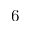<formula> <loc_0><loc_0><loc_500><loc_500>6</formula> 